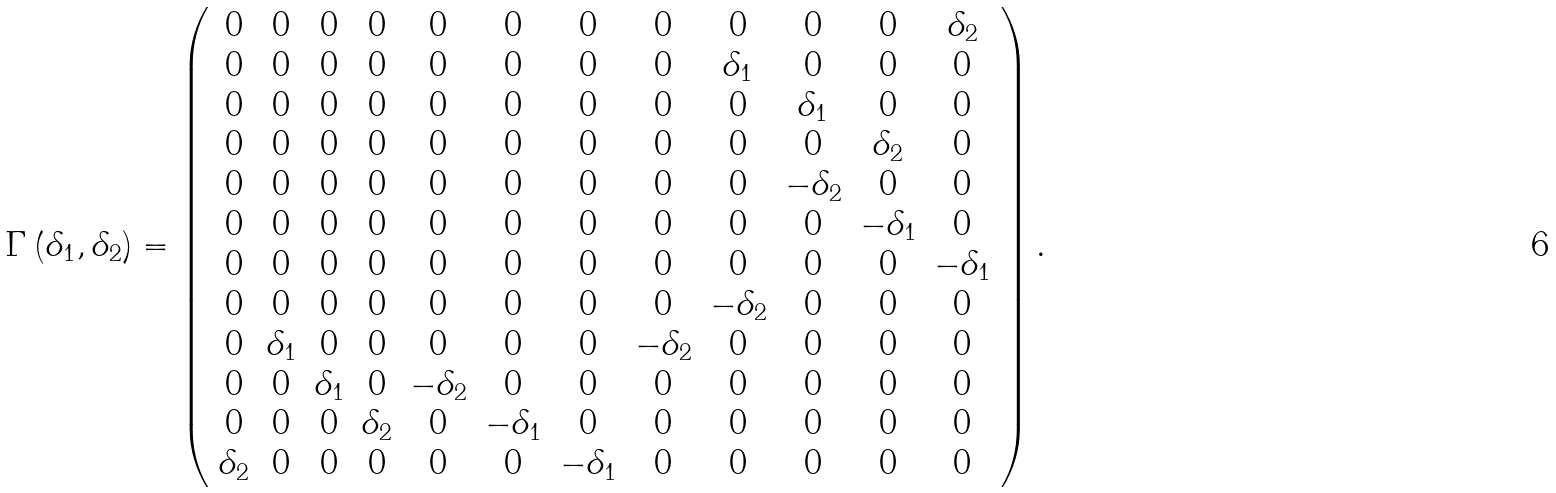Convert formula to latex. <formula><loc_0><loc_0><loc_500><loc_500>\Gamma \left ( \delta _ { 1 } , \delta _ { 2 } \right ) = \left ( \begin{array} { c c c c c c c c c c c c } 0 & 0 & 0 & 0 & 0 & 0 & 0 & 0 & 0 & 0 & 0 & \delta _ { 2 } \\ 0 & 0 & 0 & 0 & 0 & 0 & 0 & 0 & \delta _ { 1 } & 0 & 0 & 0 \\ 0 & 0 & 0 & 0 & 0 & 0 & 0 & 0 & 0 & \delta _ { 1 } & 0 & 0 \\ 0 & 0 & 0 & 0 & 0 & 0 & 0 & 0 & 0 & 0 & \delta _ { 2 } & 0 \\ 0 & 0 & 0 & 0 & 0 & 0 & 0 & 0 & 0 & - \delta _ { 2 } & 0 & 0 \\ 0 & 0 & 0 & 0 & 0 & 0 & 0 & 0 & 0 & 0 & - \delta _ { 1 } & 0 \\ 0 & 0 & 0 & 0 & 0 & 0 & 0 & 0 & 0 & 0 & 0 & - \delta _ { 1 } \\ 0 & 0 & 0 & 0 & 0 & 0 & 0 & 0 & - \delta _ { 2 } & 0 & 0 & 0 \\ 0 & \delta _ { 1 } & 0 & 0 & 0 & 0 & 0 & - \delta _ { 2 } & 0 & 0 & 0 & 0 \\ 0 & 0 & \delta _ { 1 } & 0 & - \delta _ { 2 } & 0 & 0 & 0 & 0 & 0 & 0 & 0 \\ 0 & 0 & 0 & \delta _ { 2 } & 0 & - \delta _ { 1 } & 0 & 0 & 0 & 0 & 0 & 0 \\ \delta _ { 2 } & 0 & 0 & 0 & 0 & 0 & - \delta _ { 1 } & 0 & 0 & 0 & 0 & 0 \end{array} \right ) .</formula> 